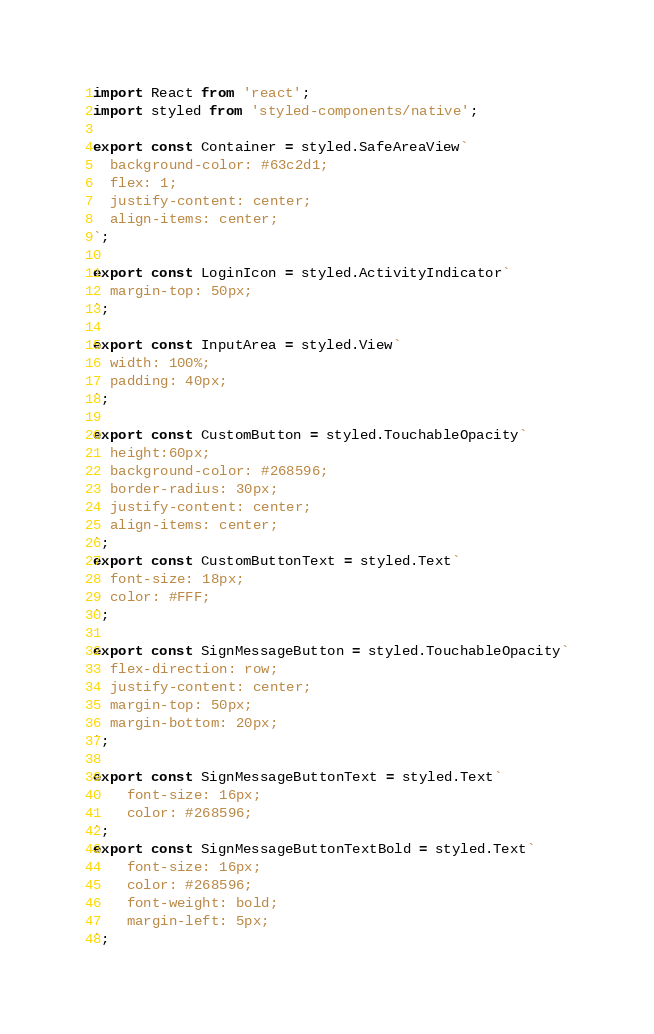<code> <loc_0><loc_0><loc_500><loc_500><_JavaScript_>import React from 'react';
import styled from 'styled-components/native';

export const Container = styled.SafeAreaView`
  background-color: #63c2d1;
  flex: 1;
  justify-content: center;
  align-items: center;
`;

export const LoginIcon = styled.ActivityIndicator`
  margin-top: 50px;
`;

export const InputArea = styled.View`
  width: 100%;
  padding: 40px;
`;

export const CustomButton = styled.TouchableOpacity`
  height:60px;
  background-color: #268596;
  border-radius: 30px;
  justify-content: center;
  align-items: center;
`;
export const CustomButtonText = styled.Text`
  font-size: 18px;
  color: #FFF;
`;

export const SignMessageButton = styled.TouchableOpacity`
  flex-direction: row;
  justify-content: center;
  margin-top: 50px;
  margin-bottom: 20px;
`;

export const SignMessageButtonText = styled.Text`
    font-size: 16px;
    color: #268596;
`;
export const SignMessageButtonTextBold = styled.Text`
    font-size: 16px;
    color: #268596;
    font-weight: bold;
    margin-left: 5px;
`;
</code> 